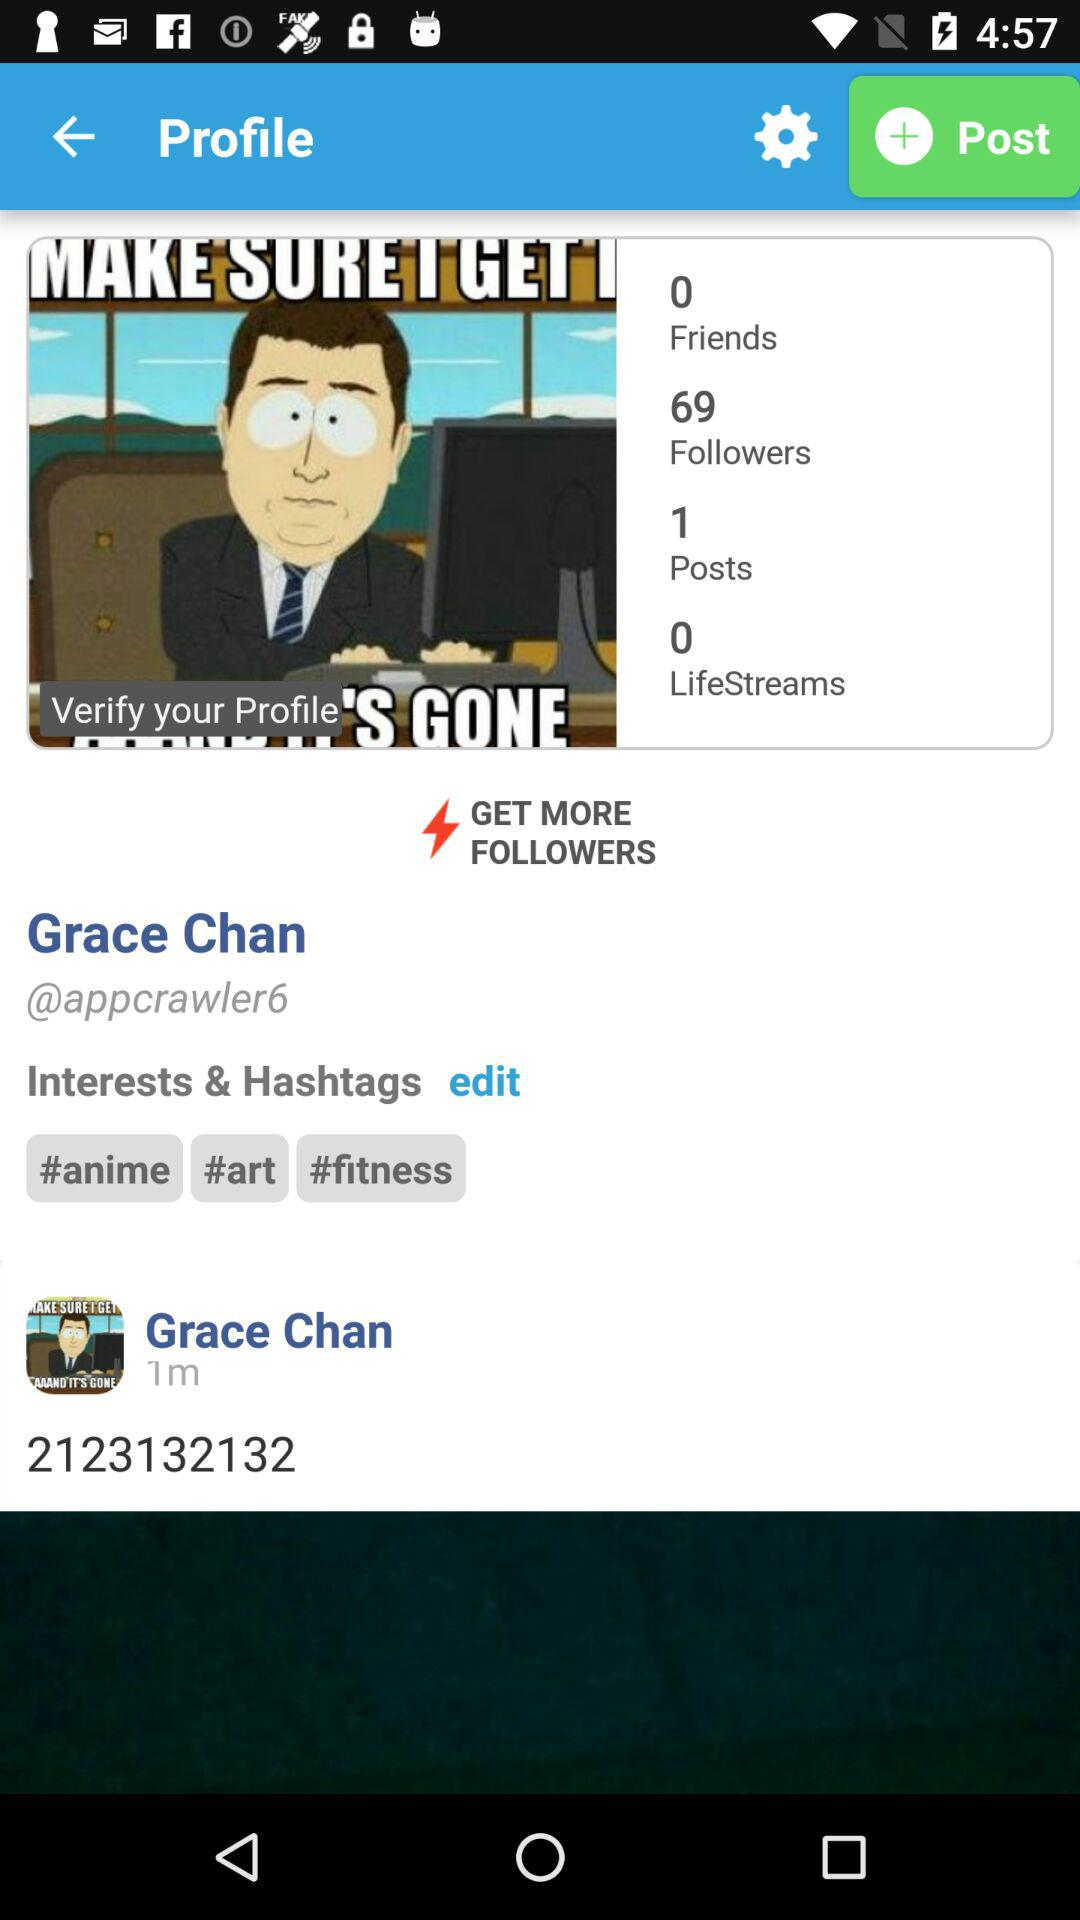How many posts are there? There is 1 post. 